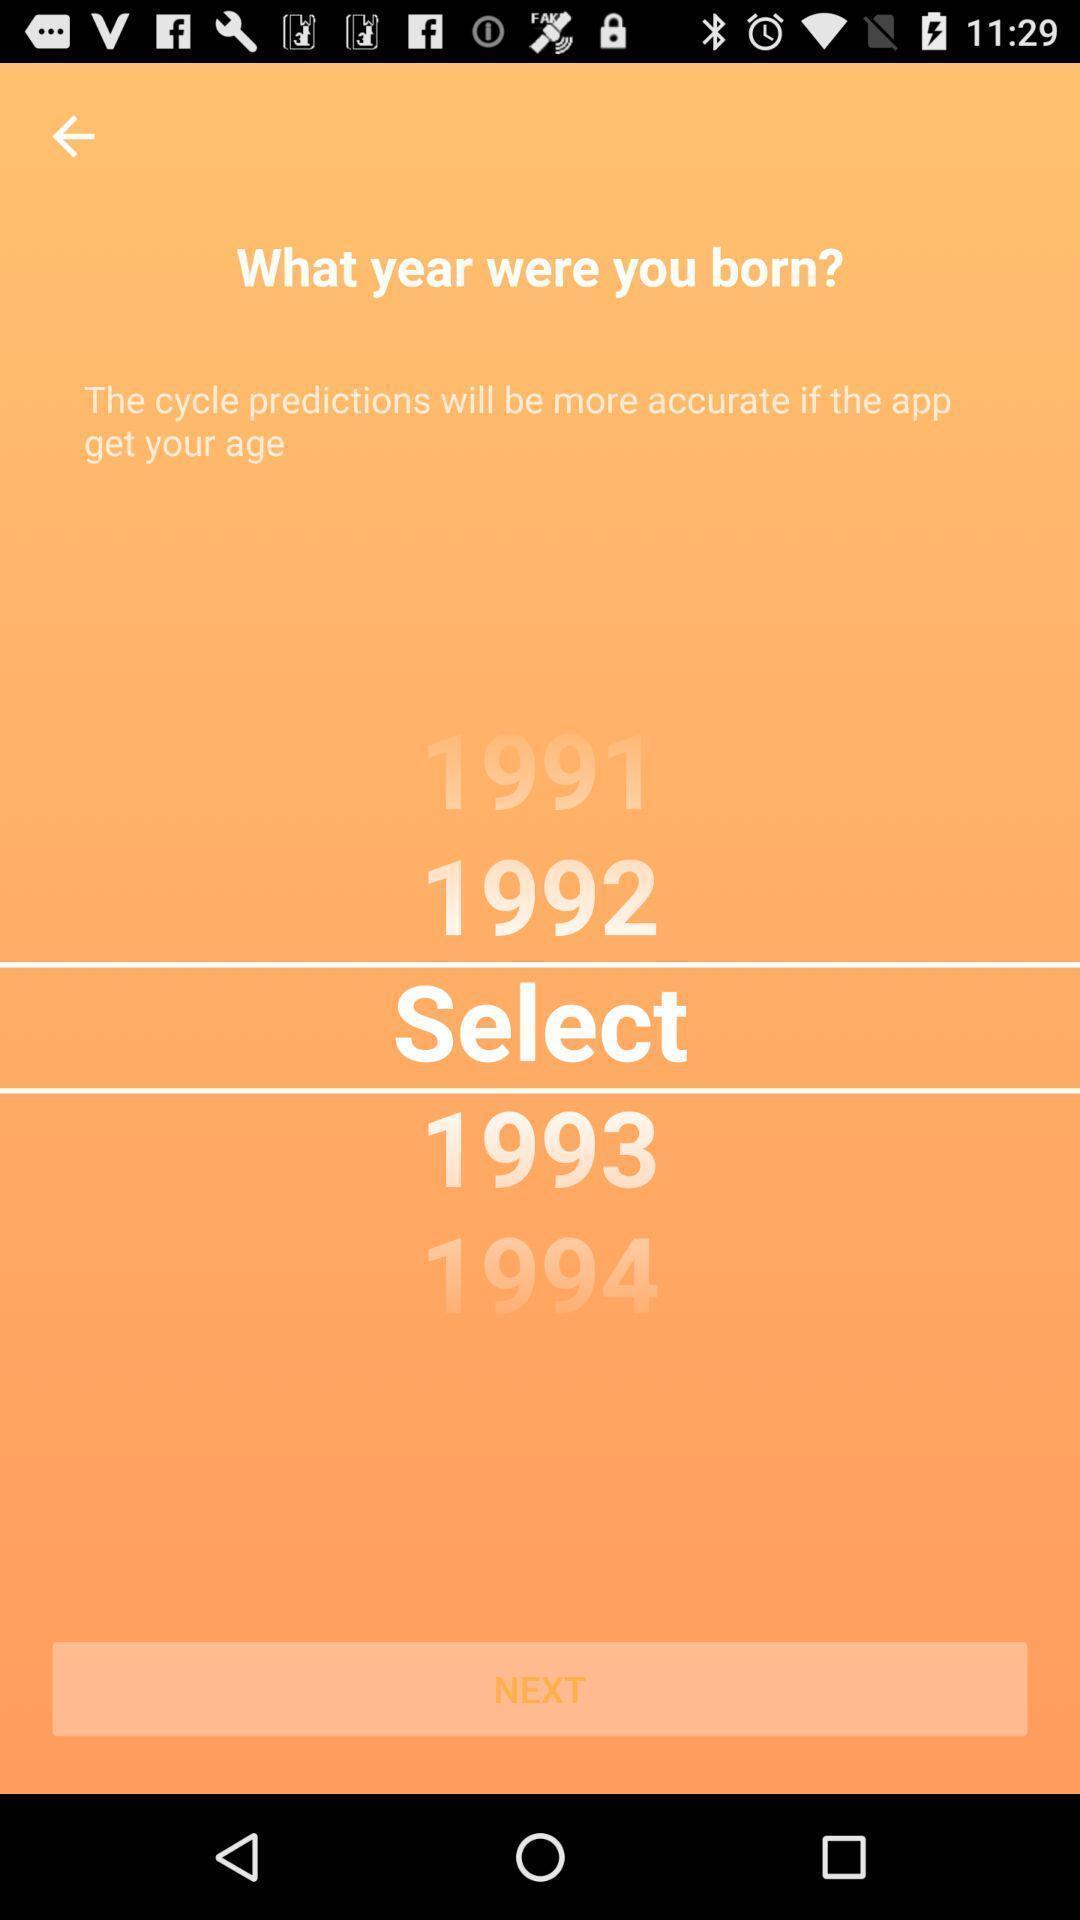Describe the key features of this screenshot. Select the date of birth year. 